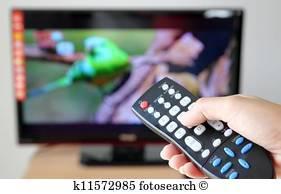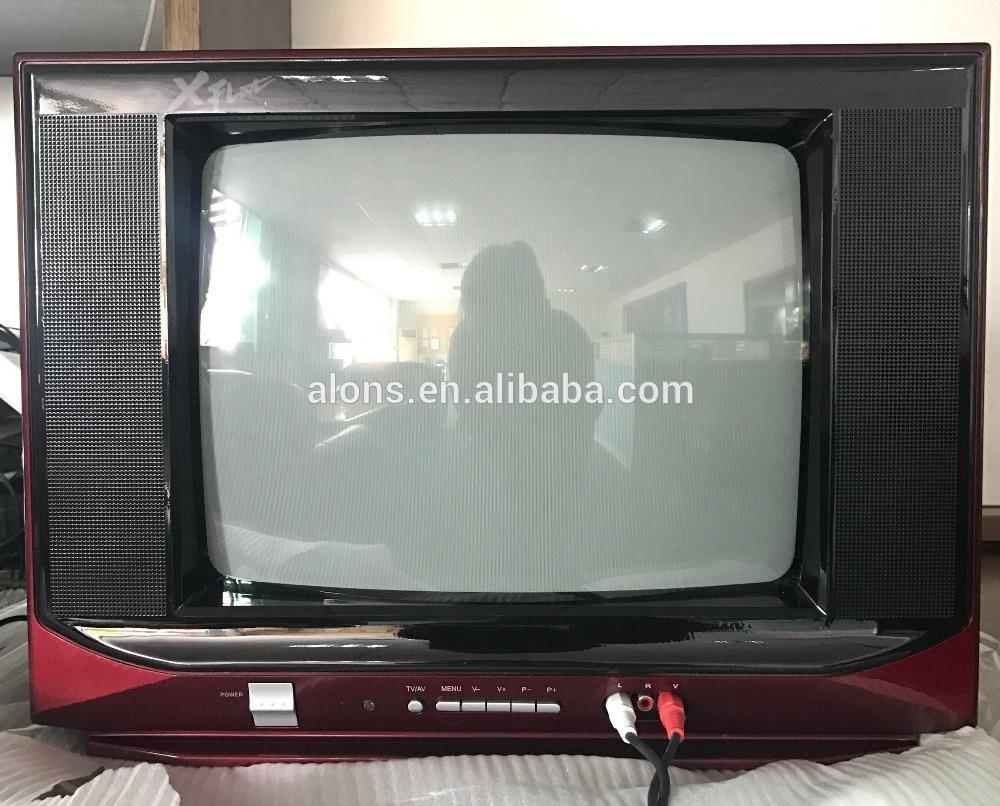The first image is the image on the left, the second image is the image on the right. Examine the images to the left and right. Is the description "There is a single television that is off in the image on the right." accurate? Answer yes or no. Yes. The first image is the image on the left, the second image is the image on the right. Examine the images to the left and right. Is the description "An image shows a group of screened appliances stacked on top of one another." accurate? Answer yes or no. No. 